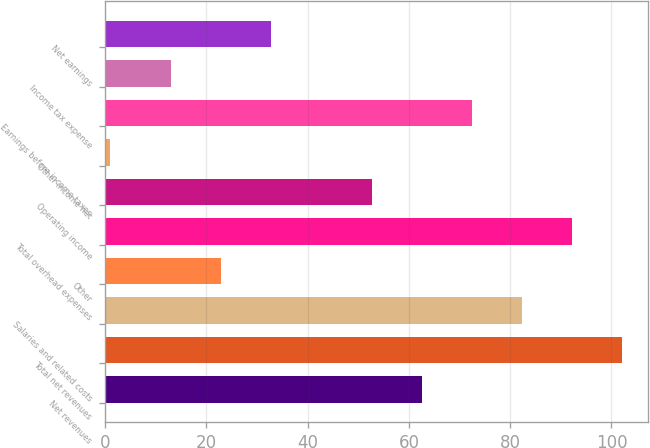<chart> <loc_0><loc_0><loc_500><loc_500><bar_chart><fcel>Net revenues<fcel>Total net revenues<fcel>Salaries and related costs<fcel>Other<fcel>Total overhead expenses<fcel>Operating income<fcel>Other income net<fcel>Earnings before income taxes<fcel>Income tax expense<fcel>Net earnings<nl><fcel>62.5<fcel>102.1<fcel>82.3<fcel>22.9<fcel>92.2<fcel>52.6<fcel>1<fcel>72.4<fcel>13<fcel>32.8<nl></chart> 